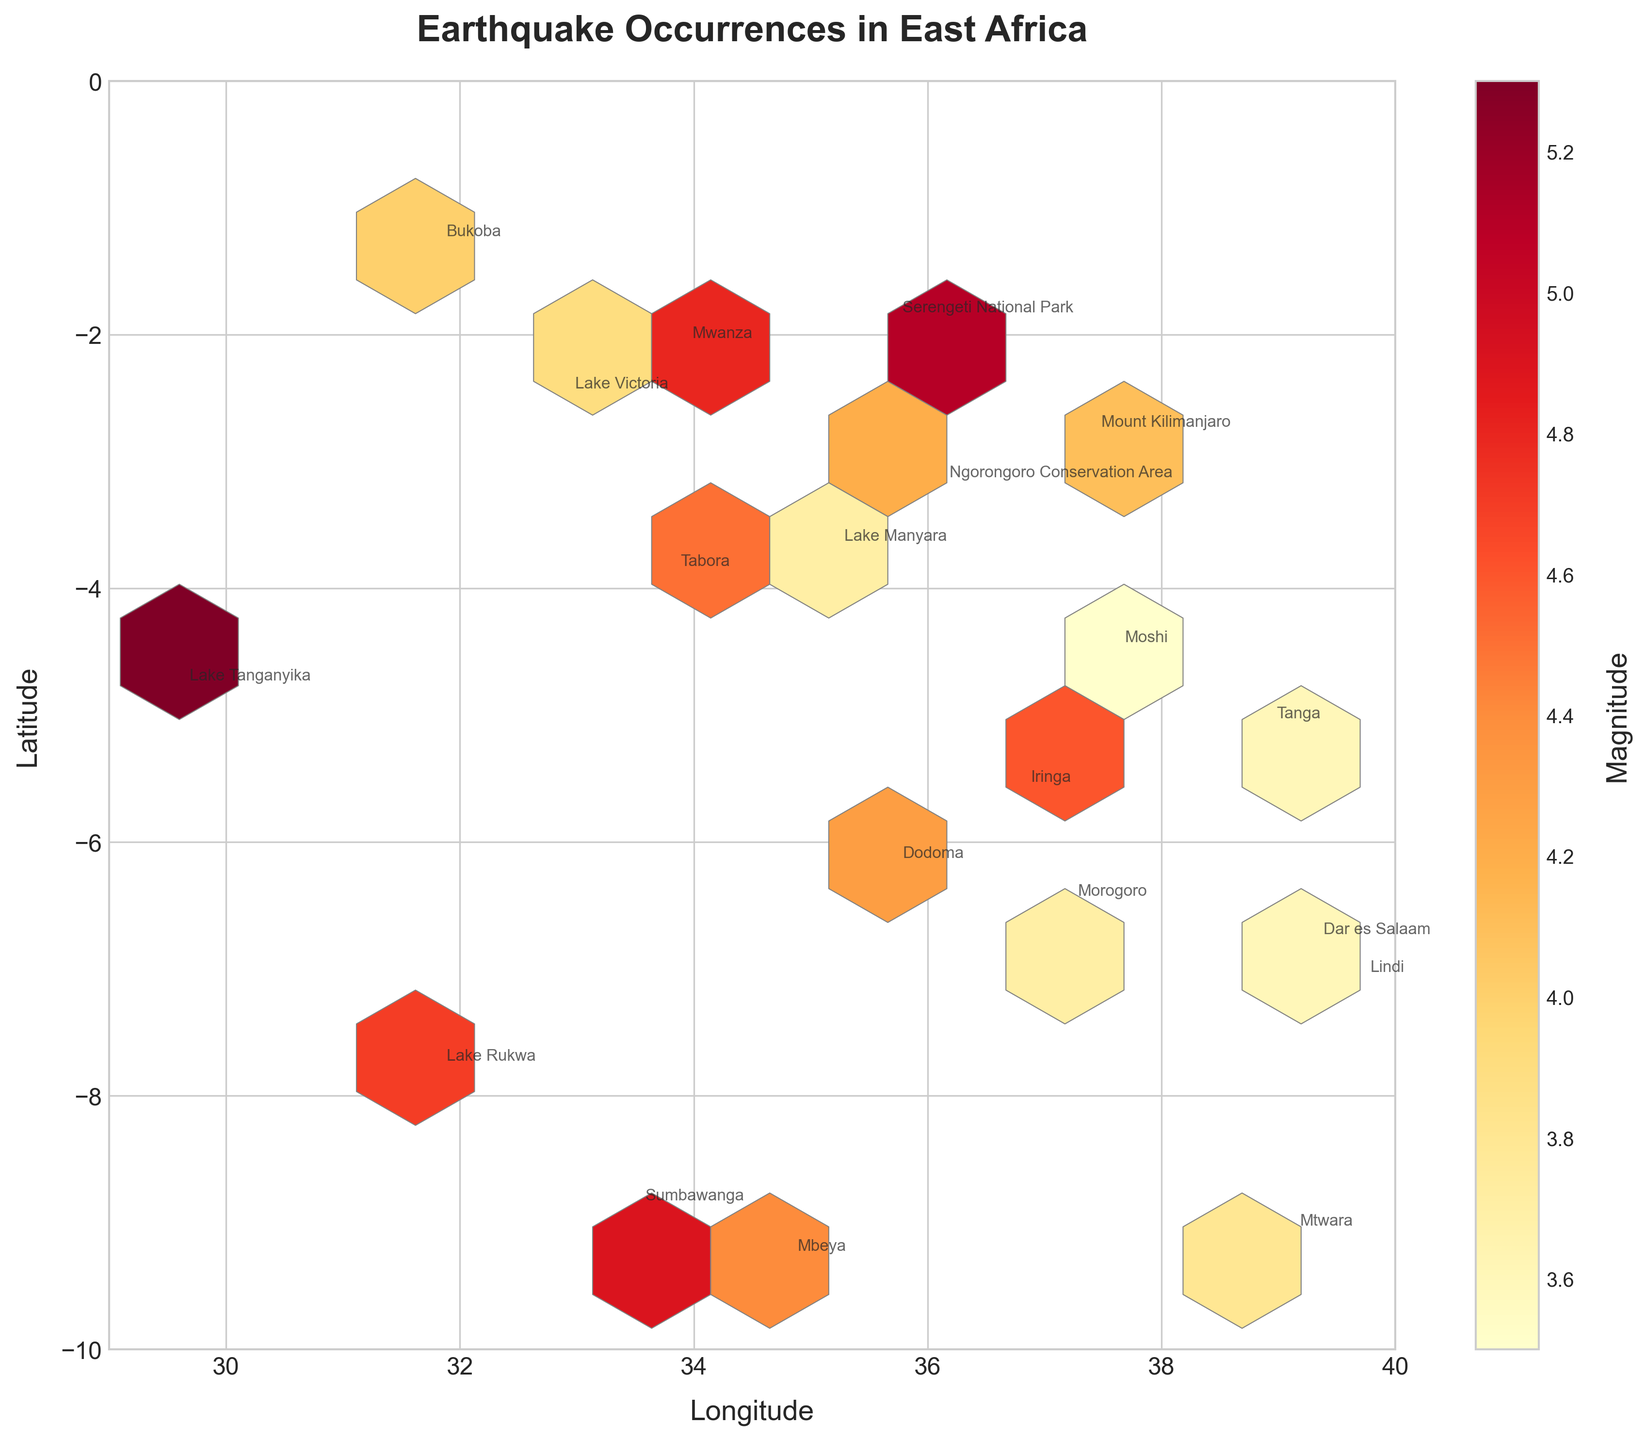What is the title of the plot? Look for the text that is styled larger and bolder, usually at the top of the plot. This text represents the title.
Answer: Earthquake Occurrences in East Africa What do the x and y labels represent? Check the text labels next to the axes. The label for the x-axis is to the right of the horizontal line, and the label for the y-axis is above the vertical line.
Answer: Longitude (x-axis) and Latitude (y-axis) Which location has the highest magnitude earthquake? Look for the highest value indicated by the color scale (cmap='YlOrRd'). Then find the associated annotation label for that hexagonal bin.
Answer: Lake Tanganyika, with a magnitude of 5.3 What is the range of longitudes shown in the plot? Check the x-axis bounds indicated by the start and end values on the horizontal line.
Answer: 29 to 40 Which locations fall within the longitude range of 35 to 38? Identify the locations whose longitude coordinates lie between the values 35 to 38. Check these on the x-axis and cross-reference with the annotated locations.
Answer: Serengeti National Park, Moshi, Mount Kilimanjaro, Lake Manyara, Dodoma, Tabora, Morogoro, Iringa Where is the most densely clustered area of earthquakes in East Africa as shown in the plot? Observe where the hexagon density is highest and where the color intensity is most prominent.
Answer: Around Dodoma What is the average magnitude of earthquakes at locations between latitude -4 and -2? Find the locations within the latitude range -4 to -2 then compute the average of their magnitudes.
Answer: (4.2 + 3.9 + 4.1 + 4.5 + 3.7) / 5 = 4.08 Which location had the deepest earthquake, and what is its depth? Look at the depth information from the dataset and compare it to find the highest depth value and its corresponding location. Verify with any annotation present.
Answer: Lake Tanganyika, 30 Are there more earthquakes in the northern or the southern part of the plotted region? Check the number of annotations above and below the midpoint of the latitude range (latitude ~ -5). Count the locations in each part to compare.
Answer: Southern part What is the latitude and longitude of the location with the lowest magnitude earthquake? Find the lowest magnitude in the dataset then confirm it against the annotated list in the plot.
Answer: Lindi, with latitude -7.1 and longitude 39.7 